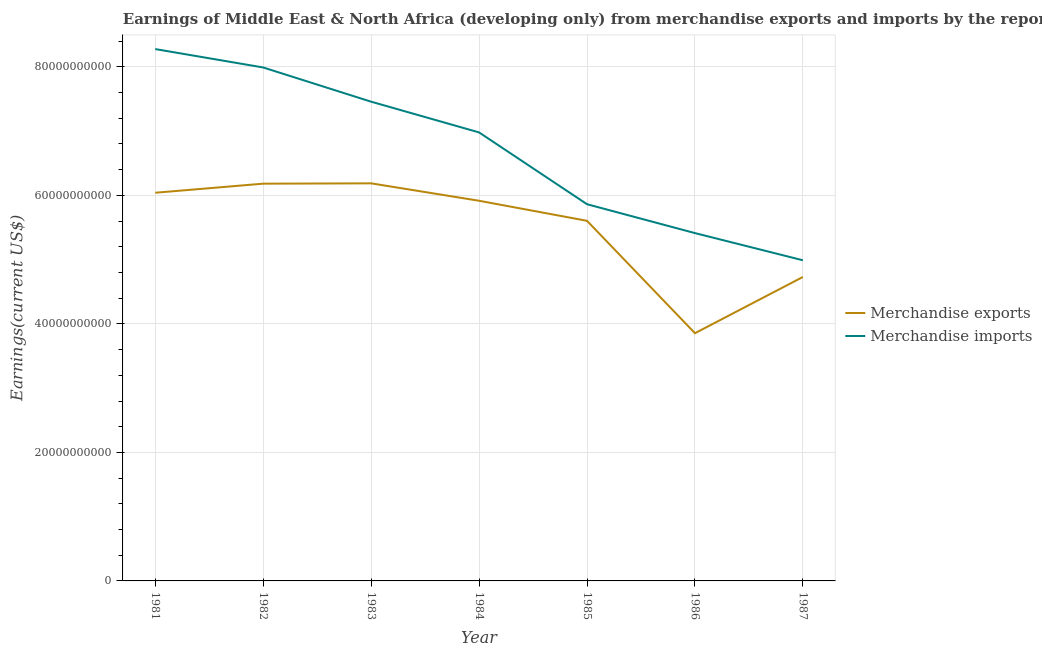How many different coloured lines are there?
Keep it short and to the point. 2. Does the line corresponding to earnings from merchandise exports intersect with the line corresponding to earnings from merchandise imports?
Make the answer very short. No. What is the earnings from merchandise exports in 1983?
Make the answer very short. 6.19e+1. Across all years, what is the maximum earnings from merchandise imports?
Offer a very short reply. 8.28e+1. Across all years, what is the minimum earnings from merchandise imports?
Make the answer very short. 4.99e+1. In which year was the earnings from merchandise imports maximum?
Your response must be concise. 1981. What is the total earnings from merchandise exports in the graph?
Offer a terse response. 3.85e+11. What is the difference between the earnings from merchandise imports in 1981 and that in 1983?
Offer a terse response. 8.19e+09. What is the difference between the earnings from merchandise exports in 1983 and the earnings from merchandise imports in 1987?
Make the answer very short. 1.20e+1. What is the average earnings from merchandise exports per year?
Your response must be concise. 5.50e+1. In the year 1982, what is the difference between the earnings from merchandise exports and earnings from merchandise imports?
Give a very brief answer. -1.81e+1. In how many years, is the earnings from merchandise exports greater than 64000000000 US$?
Give a very brief answer. 0. What is the ratio of the earnings from merchandise imports in 1984 to that in 1986?
Your answer should be compact. 1.29. Is the earnings from merchandise exports in 1981 less than that in 1985?
Make the answer very short. No. Is the difference between the earnings from merchandise exports in 1983 and 1985 greater than the difference between the earnings from merchandise imports in 1983 and 1985?
Keep it short and to the point. No. What is the difference between the highest and the second highest earnings from merchandise exports?
Your answer should be very brief. 5.15e+07. What is the difference between the highest and the lowest earnings from merchandise exports?
Make the answer very short. 2.33e+1. Is the sum of the earnings from merchandise imports in 1983 and 1986 greater than the maximum earnings from merchandise exports across all years?
Offer a very short reply. Yes. Does the earnings from merchandise exports monotonically increase over the years?
Provide a succinct answer. No. How many lines are there?
Provide a succinct answer. 2. How many years are there in the graph?
Offer a very short reply. 7. Are the values on the major ticks of Y-axis written in scientific E-notation?
Your response must be concise. No. Does the graph contain grids?
Offer a terse response. Yes. How are the legend labels stacked?
Offer a terse response. Vertical. What is the title of the graph?
Provide a succinct answer. Earnings of Middle East & North Africa (developing only) from merchandise exports and imports by the reporting economy. Does "Female labor force" appear as one of the legend labels in the graph?
Your answer should be very brief. No. What is the label or title of the X-axis?
Ensure brevity in your answer.  Year. What is the label or title of the Y-axis?
Offer a very short reply. Earnings(current US$). What is the Earnings(current US$) of Merchandise exports in 1981?
Ensure brevity in your answer.  6.04e+1. What is the Earnings(current US$) of Merchandise imports in 1981?
Offer a terse response. 8.28e+1. What is the Earnings(current US$) in Merchandise exports in 1982?
Your answer should be very brief. 6.18e+1. What is the Earnings(current US$) in Merchandise imports in 1982?
Provide a short and direct response. 7.99e+1. What is the Earnings(current US$) in Merchandise exports in 1983?
Give a very brief answer. 6.19e+1. What is the Earnings(current US$) of Merchandise imports in 1983?
Make the answer very short. 7.46e+1. What is the Earnings(current US$) in Merchandise exports in 1984?
Make the answer very short. 5.92e+1. What is the Earnings(current US$) of Merchandise imports in 1984?
Offer a very short reply. 6.98e+1. What is the Earnings(current US$) of Merchandise exports in 1985?
Offer a very short reply. 5.60e+1. What is the Earnings(current US$) of Merchandise imports in 1985?
Ensure brevity in your answer.  5.86e+1. What is the Earnings(current US$) in Merchandise exports in 1986?
Make the answer very short. 3.86e+1. What is the Earnings(current US$) in Merchandise imports in 1986?
Make the answer very short. 5.41e+1. What is the Earnings(current US$) of Merchandise exports in 1987?
Give a very brief answer. 4.73e+1. What is the Earnings(current US$) in Merchandise imports in 1987?
Make the answer very short. 4.99e+1. Across all years, what is the maximum Earnings(current US$) in Merchandise exports?
Your response must be concise. 6.19e+1. Across all years, what is the maximum Earnings(current US$) in Merchandise imports?
Your answer should be very brief. 8.28e+1. Across all years, what is the minimum Earnings(current US$) of Merchandise exports?
Make the answer very short. 3.86e+1. Across all years, what is the minimum Earnings(current US$) of Merchandise imports?
Ensure brevity in your answer.  4.99e+1. What is the total Earnings(current US$) of Merchandise exports in the graph?
Offer a terse response. 3.85e+11. What is the total Earnings(current US$) in Merchandise imports in the graph?
Provide a short and direct response. 4.70e+11. What is the difference between the Earnings(current US$) of Merchandise exports in 1981 and that in 1982?
Make the answer very short. -1.41e+09. What is the difference between the Earnings(current US$) in Merchandise imports in 1981 and that in 1982?
Offer a very short reply. 2.86e+09. What is the difference between the Earnings(current US$) in Merchandise exports in 1981 and that in 1983?
Offer a terse response. -1.46e+09. What is the difference between the Earnings(current US$) in Merchandise imports in 1981 and that in 1983?
Provide a succinct answer. 8.19e+09. What is the difference between the Earnings(current US$) of Merchandise exports in 1981 and that in 1984?
Offer a very short reply. 1.25e+09. What is the difference between the Earnings(current US$) of Merchandise imports in 1981 and that in 1984?
Your answer should be very brief. 1.30e+1. What is the difference between the Earnings(current US$) in Merchandise exports in 1981 and that in 1985?
Provide a succinct answer. 4.37e+09. What is the difference between the Earnings(current US$) of Merchandise imports in 1981 and that in 1985?
Keep it short and to the point. 2.41e+1. What is the difference between the Earnings(current US$) in Merchandise exports in 1981 and that in 1986?
Offer a terse response. 2.19e+1. What is the difference between the Earnings(current US$) of Merchandise imports in 1981 and that in 1986?
Offer a very short reply. 2.86e+1. What is the difference between the Earnings(current US$) of Merchandise exports in 1981 and that in 1987?
Give a very brief answer. 1.31e+1. What is the difference between the Earnings(current US$) of Merchandise imports in 1981 and that in 1987?
Your answer should be very brief. 3.29e+1. What is the difference between the Earnings(current US$) of Merchandise exports in 1982 and that in 1983?
Offer a very short reply. -5.15e+07. What is the difference between the Earnings(current US$) in Merchandise imports in 1982 and that in 1983?
Keep it short and to the point. 5.33e+09. What is the difference between the Earnings(current US$) of Merchandise exports in 1982 and that in 1984?
Give a very brief answer. 2.66e+09. What is the difference between the Earnings(current US$) of Merchandise imports in 1982 and that in 1984?
Your answer should be very brief. 1.01e+1. What is the difference between the Earnings(current US$) of Merchandise exports in 1982 and that in 1985?
Ensure brevity in your answer.  5.78e+09. What is the difference between the Earnings(current US$) in Merchandise imports in 1982 and that in 1985?
Keep it short and to the point. 2.13e+1. What is the difference between the Earnings(current US$) of Merchandise exports in 1982 and that in 1986?
Your response must be concise. 2.33e+1. What is the difference between the Earnings(current US$) of Merchandise imports in 1982 and that in 1986?
Make the answer very short. 2.58e+1. What is the difference between the Earnings(current US$) of Merchandise exports in 1982 and that in 1987?
Offer a very short reply. 1.45e+1. What is the difference between the Earnings(current US$) of Merchandise imports in 1982 and that in 1987?
Offer a very short reply. 3.00e+1. What is the difference between the Earnings(current US$) of Merchandise exports in 1983 and that in 1984?
Make the answer very short. 2.71e+09. What is the difference between the Earnings(current US$) of Merchandise imports in 1983 and that in 1984?
Keep it short and to the point. 4.78e+09. What is the difference between the Earnings(current US$) of Merchandise exports in 1983 and that in 1985?
Your response must be concise. 5.83e+09. What is the difference between the Earnings(current US$) in Merchandise imports in 1983 and that in 1985?
Offer a terse response. 1.60e+1. What is the difference between the Earnings(current US$) of Merchandise exports in 1983 and that in 1986?
Your answer should be very brief. 2.33e+1. What is the difference between the Earnings(current US$) of Merchandise imports in 1983 and that in 1986?
Keep it short and to the point. 2.04e+1. What is the difference between the Earnings(current US$) in Merchandise exports in 1983 and that in 1987?
Offer a very short reply. 1.46e+1. What is the difference between the Earnings(current US$) of Merchandise imports in 1983 and that in 1987?
Offer a very short reply. 2.47e+1. What is the difference between the Earnings(current US$) of Merchandise exports in 1984 and that in 1985?
Your answer should be compact. 3.12e+09. What is the difference between the Earnings(current US$) of Merchandise imports in 1984 and that in 1985?
Your response must be concise. 1.12e+1. What is the difference between the Earnings(current US$) in Merchandise exports in 1984 and that in 1986?
Your response must be concise. 2.06e+1. What is the difference between the Earnings(current US$) in Merchandise imports in 1984 and that in 1986?
Your answer should be very brief. 1.57e+1. What is the difference between the Earnings(current US$) in Merchandise exports in 1984 and that in 1987?
Make the answer very short. 1.19e+1. What is the difference between the Earnings(current US$) in Merchandise imports in 1984 and that in 1987?
Make the answer very short. 1.99e+1. What is the difference between the Earnings(current US$) in Merchandise exports in 1985 and that in 1986?
Make the answer very short. 1.75e+1. What is the difference between the Earnings(current US$) in Merchandise imports in 1985 and that in 1986?
Give a very brief answer. 4.49e+09. What is the difference between the Earnings(current US$) of Merchandise exports in 1985 and that in 1987?
Your response must be concise. 8.74e+09. What is the difference between the Earnings(current US$) of Merchandise imports in 1985 and that in 1987?
Keep it short and to the point. 8.72e+09. What is the difference between the Earnings(current US$) of Merchandise exports in 1986 and that in 1987?
Ensure brevity in your answer.  -8.75e+09. What is the difference between the Earnings(current US$) in Merchandise imports in 1986 and that in 1987?
Your answer should be compact. 4.23e+09. What is the difference between the Earnings(current US$) in Merchandise exports in 1981 and the Earnings(current US$) in Merchandise imports in 1982?
Provide a short and direct response. -1.95e+1. What is the difference between the Earnings(current US$) of Merchandise exports in 1981 and the Earnings(current US$) of Merchandise imports in 1983?
Provide a succinct answer. -1.42e+1. What is the difference between the Earnings(current US$) in Merchandise exports in 1981 and the Earnings(current US$) in Merchandise imports in 1984?
Offer a terse response. -9.39e+09. What is the difference between the Earnings(current US$) of Merchandise exports in 1981 and the Earnings(current US$) of Merchandise imports in 1985?
Your answer should be very brief. 1.79e+09. What is the difference between the Earnings(current US$) of Merchandise exports in 1981 and the Earnings(current US$) of Merchandise imports in 1986?
Make the answer very short. 6.28e+09. What is the difference between the Earnings(current US$) of Merchandise exports in 1981 and the Earnings(current US$) of Merchandise imports in 1987?
Make the answer very short. 1.05e+1. What is the difference between the Earnings(current US$) in Merchandise exports in 1982 and the Earnings(current US$) in Merchandise imports in 1983?
Your response must be concise. -1.28e+1. What is the difference between the Earnings(current US$) in Merchandise exports in 1982 and the Earnings(current US$) in Merchandise imports in 1984?
Make the answer very short. -7.98e+09. What is the difference between the Earnings(current US$) in Merchandise exports in 1982 and the Earnings(current US$) in Merchandise imports in 1985?
Offer a terse response. 3.20e+09. What is the difference between the Earnings(current US$) of Merchandise exports in 1982 and the Earnings(current US$) of Merchandise imports in 1986?
Your answer should be compact. 7.69e+09. What is the difference between the Earnings(current US$) of Merchandise exports in 1982 and the Earnings(current US$) of Merchandise imports in 1987?
Your answer should be compact. 1.19e+1. What is the difference between the Earnings(current US$) in Merchandise exports in 1983 and the Earnings(current US$) in Merchandise imports in 1984?
Make the answer very short. -7.93e+09. What is the difference between the Earnings(current US$) in Merchandise exports in 1983 and the Earnings(current US$) in Merchandise imports in 1985?
Offer a terse response. 3.25e+09. What is the difference between the Earnings(current US$) of Merchandise exports in 1983 and the Earnings(current US$) of Merchandise imports in 1986?
Ensure brevity in your answer.  7.74e+09. What is the difference between the Earnings(current US$) of Merchandise exports in 1983 and the Earnings(current US$) of Merchandise imports in 1987?
Give a very brief answer. 1.20e+1. What is the difference between the Earnings(current US$) in Merchandise exports in 1984 and the Earnings(current US$) in Merchandise imports in 1985?
Offer a very short reply. 5.38e+08. What is the difference between the Earnings(current US$) in Merchandise exports in 1984 and the Earnings(current US$) in Merchandise imports in 1986?
Offer a very short reply. 5.03e+09. What is the difference between the Earnings(current US$) in Merchandise exports in 1984 and the Earnings(current US$) in Merchandise imports in 1987?
Your answer should be compact. 9.26e+09. What is the difference between the Earnings(current US$) in Merchandise exports in 1985 and the Earnings(current US$) in Merchandise imports in 1986?
Provide a short and direct response. 1.91e+09. What is the difference between the Earnings(current US$) of Merchandise exports in 1985 and the Earnings(current US$) of Merchandise imports in 1987?
Provide a succinct answer. 6.14e+09. What is the difference between the Earnings(current US$) in Merchandise exports in 1986 and the Earnings(current US$) in Merchandise imports in 1987?
Offer a terse response. -1.13e+1. What is the average Earnings(current US$) of Merchandise exports per year?
Your response must be concise. 5.50e+1. What is the average Earnings(current US$) in Merchandise imports per year?
Keep it short and to the point. 6.71e+1. In the year 1981, what is the difference between the Earnings(current US$) in Merchandise exports and Earnings(current US$) in Merchandise imports?
Your answer should be compact. -2.24e+1. In the year 1982, what is the difference between the Earnings(current US$) in Merchandise exports and Earnings(current US$) in Merchandise imports?
Your answer should be very brief. -1.81e+1. In the year 1983, what is the difference between the Earnings(current US$) in Merchandise exports and Earnings(current US$) in Merchandise imports?
Provide a short and direct response. -1.27e+1. In the year 1984, what is the difference between the Earnings(current US$) in Merchandise exports and Earnings(current US$) in Merchandise imports?
Ensure brevity in your answer.  -1.06e+1. In the year 1985, what is the difference between the Earnings(current US$) in Merchandise exports and Earnings(current US$) in Merchandise imports?
Your answer should be compact. -2.58e+09. In the year 1986, what is the difference between the Earnings(current US$) in Merchandise exports and Earnings(current US$) in Merchandise imports?
Your answer should be very brief. -1.56e+1. In the year 1987, what is the difference between the Earnings(current US$) in Merchandise exports and Earnings(current US$) in Merchandise imports?
Offer a terse response. -2.60e+09. What is the ratio of the Earnings(current US$) of Merchandise exports in 1981 to that in 1982?
Make the answer very short. 0.98. What is the ratio of the Earnings(current US$) in Merchandise imports in 1981 to that in 1982?
Make the answer very short. 1.04. What is the ratio of the Earnings(current US$) in Merchandise exports in 1981 to that in 1983?
Make the answer very short. 0.98. What is the ratio of the Earnings(current US$) in Merchandise imports in 1981 to that in 1983?
Ensure brevity in your answer.  1.11. What is the ratio of the Earnings(current US$) of Merchandise exports in 1981 to that in 1984?
Give a very brief answer. 1.02. What is the ratio of the Earnings(current US$) in Merchandise imports in 1981 to that in 1984?
Your answer should be very brief. 1.19. What is the ratio of the Earnings(current US$) in Merchandise exports in 1981 to that in 1985?
Give a very brief answer. 1.08. What is the ratio of the Earnings(current US$) of Merchandise imports in 1981 to that in 1985?
Your answer should be compact. 1.41. What is the ratio of the Earnings(current US$) of Merchandise exports in 1981 to that in 1986?
Your answer should be compact. 1.57. What is the ratio of the Earnings(current US$) in Merchandise imports in 1981 to that in 1986?
Make the answer very short. 1.53. What is the ratio of the Earnings(current US$) of Merchandise exports in 1981 to that in 1987?
Your answer should be very brief. 1.28. What is the ratio of the Earnings(current US$) of Merchandise imports in 1981 to that in 1987?
Your answer should be compact. 1.66. What is the ratio of the Earnings(current US$) in Merchandise imports in 1982 to that in 1983?
Ensure brevity in your answer.  1.07. What is the ratio of the Earnings(current US$) of Merchandise exports in 1982 to that in 1984?
Give a very brief answer. 1.04. What is the ratio of the Earnings(current US$) of Merchandise imports in 1982 to that in 1984?
Make the answer very short. 1.14. What is the ratio of the Earnings(current US$) in Merchandise exports in 1982 to that in 1985?
Ensure brevity in your answer.  1.1. What is the ratio of the Earnings(current US$) of Merchandise imports in 1982 to that in 1985?
Offer a very short reply. 1.36. What is the ratio of the Earnings(current US$) of Merchandise exports in 1982 to that in 1986?
Give a very brief answer. 1.6. What is the ratio of the Earnings(current US$) of Merchandise imports in 1982 to that in 1986?
Your answer should be very brief. 1.48. What is the ratio of the Earnings(current US$) of Merchandise exports in 1982 to that in 1987?
Offer a terse response. 1.31. What is the ratio of the Earnings(current US$) in Merchandise imports in 1982 to that in 1987?
Provide a short and direct response. 1.6. What is the ratio of the Earnings(current US$) in Merchandise exports in 1983 to that in 1984?
Keep it short and to the point. 1.05. What is the ratio of the Earnings(current US$) in Merchandise imports in 1983 to that in 1984?
Provide a short and direct response. 1.07. What is the ratio of the Earnings(current US$) of Merchandise exports in 1983 to that in 1985?
Offer a very short reply. 1.1. What is the ratio of the Earnings(current US$) of Merchandise imports in 1983 to that in 1985?
Make the answer very short. 1.27. What is the ratio of the Earnings(current US$) in Merchandise exports in 1983 to that in 1986?
Your answer should be compact. 1.6. What is the ratio of the Earnings(current US$) in Merchandise imports in 1983 to that in 1986?
Your answer should be compact. 1.38. What is the ratio of the Earnings(current US$) in Merchandise exports in 1983 to that in 1987?
Your response must be concise. 1.31. What is the ratio of the Earnings(current US$) of Merchandise imports in 1983 to that in 1987?
Keep it short and to the point. 1.49. What is the ratio of the Earnings(current US$) in Merchandise exports in 1984 to that in 1985?
Your answer should be very brief. 1.06. What is the ratio of the Earnings(current US$) in Merchandise imports in 1984 to that in 1985?
Make the answer very short. 1.19. What is the ratio of the Earnings(current US$) in Merchandise exports in 1984 to that in 1986?
Give a very brief answer. 1.53. What is the ratio of the Earnings(current US$) in Merchandise imports in 1984 to that in 1986?
Ensure brevity in your answer.  1.29. What is the ratio of the Earnings(current US$) in Merchandise exports in 1984 to that in 1987?
Provide a succinct answer. 1.25. What is the ratio of the Earnings(current US$) in Merchandise imports in 1984 to that in 1987?
Make the answer very short. 1.4. What is the ratio of the Earnings(current US$) of Merchandise exports in 1985 to that in 1986?
Your response must be concise. 1.45. What is the ratio of the Earnings(current US$) of Merchandise imports in 1985 to that in 1986?
Make the answer very short. 1.08. What is the ratio of the Earnings(current US$) of Merchandise exports in 1985 to that in 1987?
Offer a terse response. 1.18. What is the ratio of the Earnings(current US$) in Merchandise imports in 1985 to that in 1987?
Offer a very short reply. 1.17. What is the ratio of the Earnings(current US$) in Merchandise exports in 1986 to that in 1987?
Provide a short and direct response. 0.81. What is the ratio of the Earnings(current US$) in Merchandise imports in 1986 to that in 1987?
Keep it short and to the point. 1.08. What is the difference between the highest and the second highest Earnings(current US$) in Merchandise exports?
Your answer should be compact. 5.15e+07. What is the difference between the highest and the second highest Earnings(current US$) in Merchandise imports?
Provide a succinct answer. 2.86e+09. What is the difference between the highest and the lowest Earnings(current US$) in Merchandise exports?
Your answer should be very brief. 2.33e+1. What is the difference between the highest and the lowest Earnings(current US$) of Merchandise imports?
Your answer should be compact. 3.29e+1. 